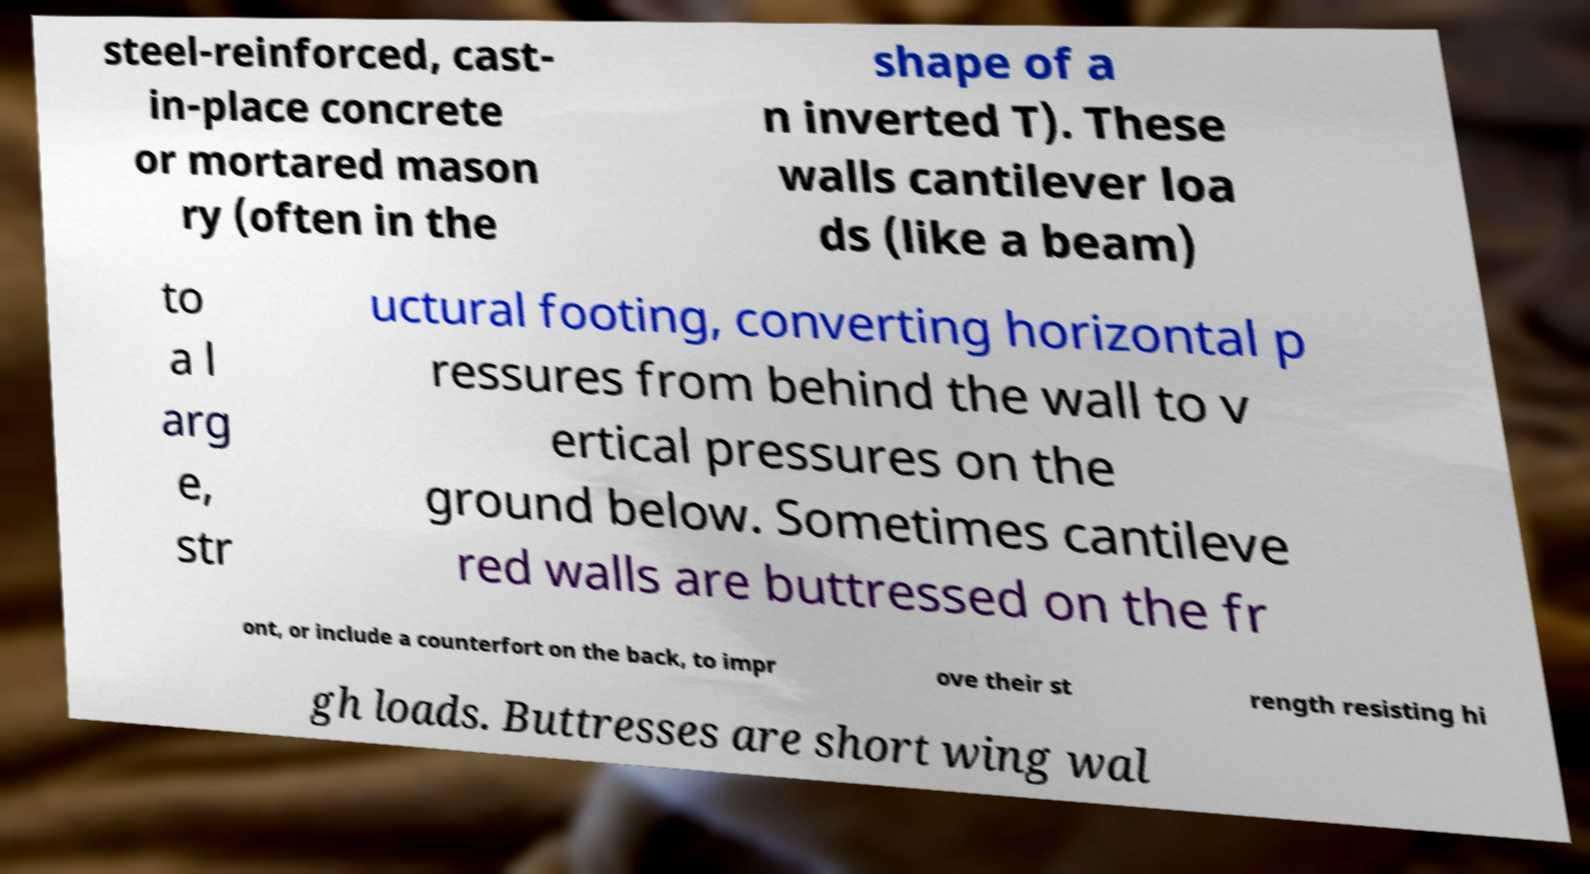For documentation purposes, I need the text within this image transcribed. Could you provide that? steel-reinforced, cast- in-place concrete or mortared mason ry (often in the shape of a n inverted T). These walls cantilever loa ds (like a beam) to a l arg e, str uctural footing, converting horizontal p ressures from behind the wall to v ertical pressures on the ground below. Sometimes cantileve red walls are buttressed on the fr ont, or include a counterfort on the back, to impr ove their st rength resisting hi gh loads. Buttresses are short wing wal 